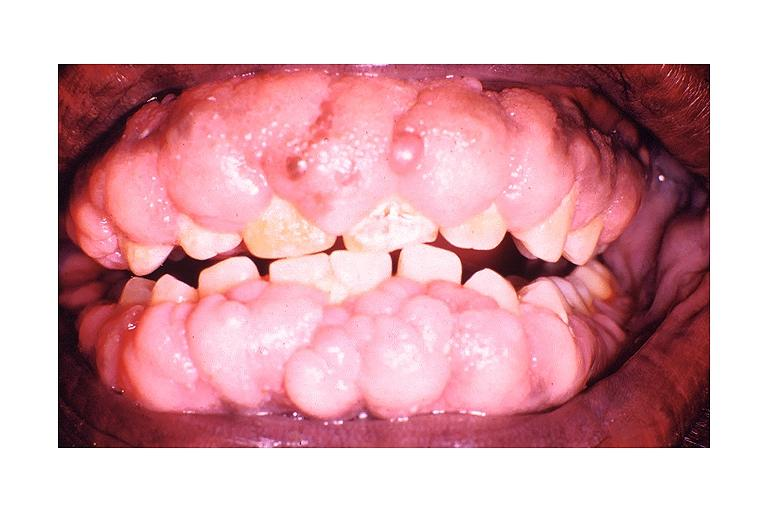s oral present?
Answer the question using a single word or phrase. Yes 